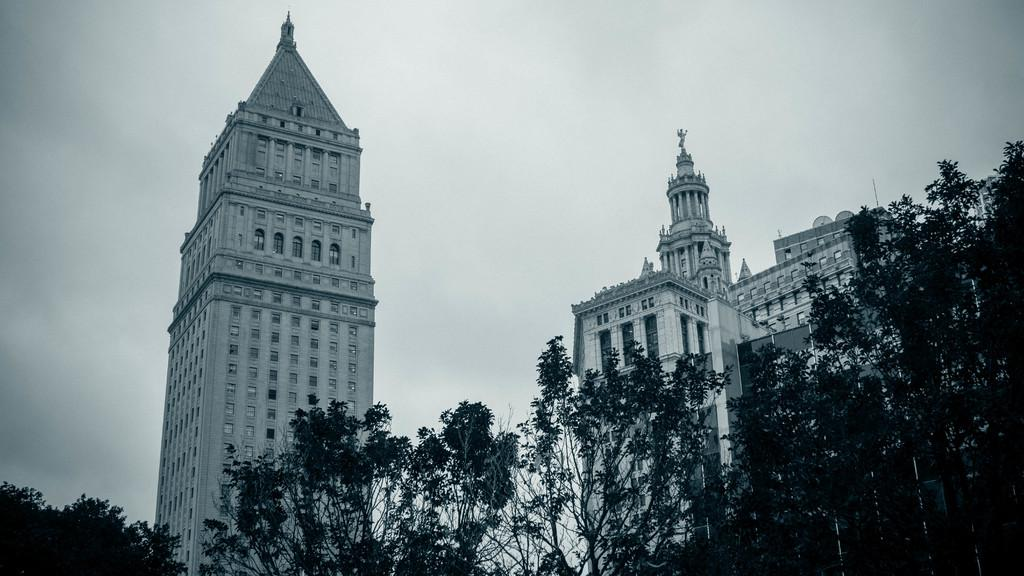What type of vegetation can be seen in the image? There are trees in the image. What is the color of the trees? The trees are green. What structures are visible in the background of the image? There are buildings in the background of the image. What is the color of the buildings? The buildings are white. What part of the natural environment is visible in the image? The sky is visible in the image. What is the color of the sky? The sky is white. What type of line can be seen connecting the trees in the image? There is no line connecting the trees in the image; the trees are separate entities. What is the needle used for in the image? There is no needle present in the image. 